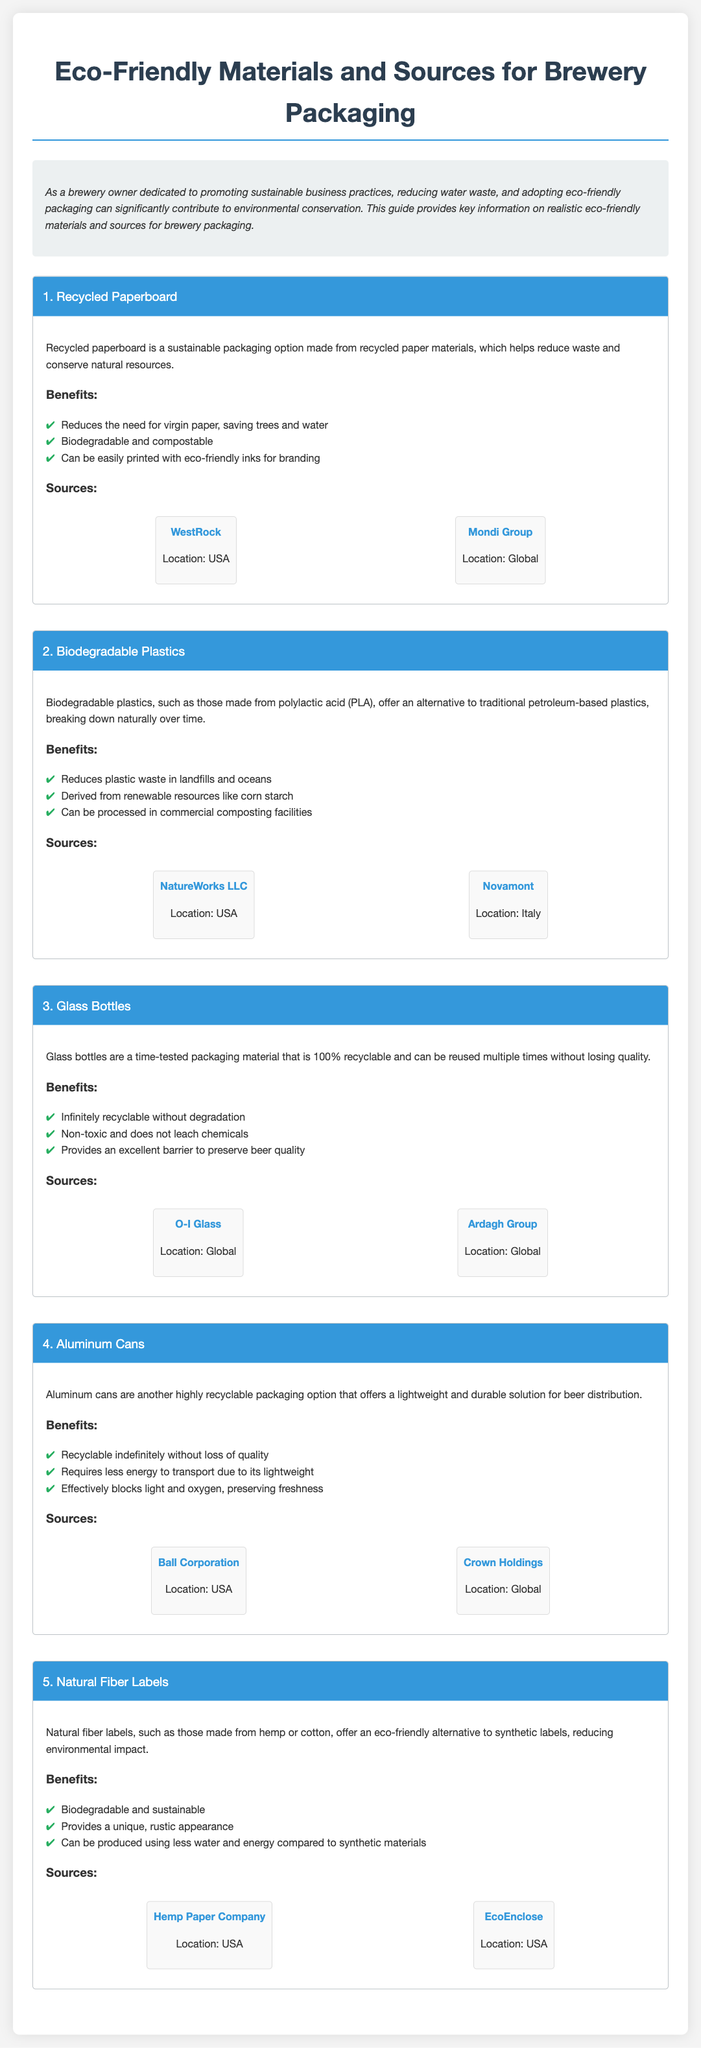What is the first eco-friendly material listed? The document starts with the material section, describing various eco-friendly materials, the first of which is Recycled Paperboard.
Answer: Recycled Paperboard What benefit does recycled paperboard provide? It lists several benefits and one key benefit is that it reduces the need for virgin paper, saving trees and water.
Answer: Reduces the need for virgin paper, saving trees and water What country is NatureWorks LLC located in? The section on Biodegradable Plastics mentions NatureWorks LLC with the location specified as USA.
Answer: USA How many benefits are listed for aluminum cans? In the Aluminum Cans section, three benefits are outlined.
Answer: Three Which company provides glass bottles globally? The section on Glass Bottles mentions O-I Glass as a global supplier.
Answer: O-I Glass What type of labels are suggested as eco-friendly? The Natural Fiber Labels section discusses natural fiber labels, specifically mentioning those made from hemp or cotton.
Answer: Natural fiber labels What is one key source of biodegradable plastics? The document provides several sources, with one mentioned source being Novamont.
Answer: Novamont How many materials are detailed in the guide? The document lists five different materials in total for eco-friendly packaging options.
Answer: Five What is a significant advantage of using glass bottles according to the guide? One significant advantage listed is that glass bottles are infinitely recyclable without degradation.
Answer: Infinitely recyclable without degradation 